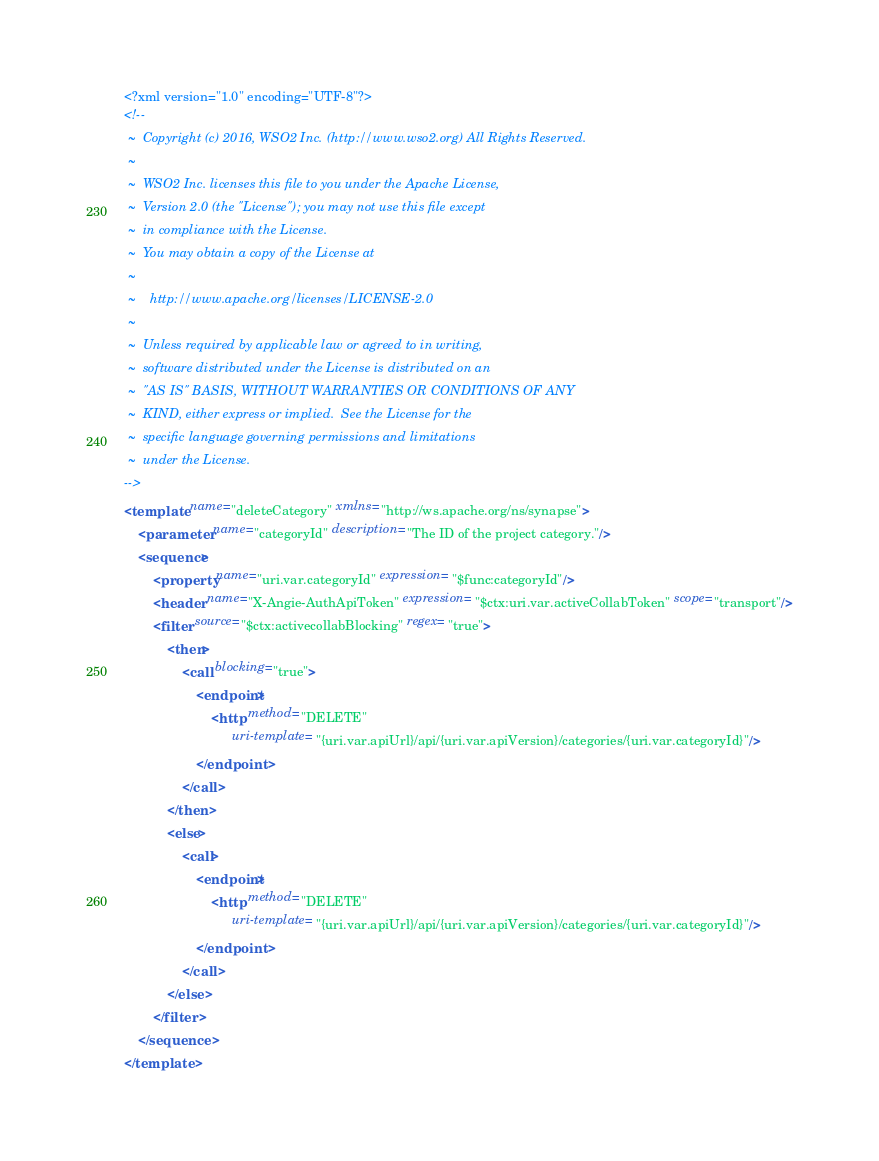<code> <loc_0><loc_0><loc_500><loc_500><_XML_><?xml version="1.0" encoding="UTF-8"?>
<!--
 ~  Copyright (c) 2016, WSO2 Inc. (http://www.wso2.org) All Rights Reserved.
 ~
 ~  WSO2 Inc. licenses this file to you under the Apache License,
 ~  Version 2.0 (the "License"); you may not use this file except
 ~  in compliance with the License.
 ~  You may obtain a copy of the License at
 ~
 ~    http://www.apache.org/licenses/LICENSE-2.0
 ~
 ~  Unless required by applicable law or agreed to in writing,
 ~  software distributed under the License is distributed on an
 ~  "AS IS" BASIS, WITHOUT WARRANTIES OR CONDITIONS OF ANY
 ~  KIND, either express or implied.  See the License for the
 ~  specific language governing permissions and limitations
 ~  under the License.
-->
<template name="deleteCategory" xmlns="http://ws.apache.org/ns/synapse">
    <parameter name="categoryId" description="The ID of the project category."/>
    <sequence>
        <property name="uri.var.categoryId" expression="$func:categoryId"/>
        <header name="X-Angie-AuthApiToken" expression="$ctx:uri.var.activeCollabToken" scope="transport"/>
        <filter source="$ctx:activecollabBlocking" regex="true">
            <then>
                <call blocking="true">
                    <endpoint>
                        <http method="DELETE"
                              uri-template="{uri.var.apiUrl}/api/{uri.var.apiVersion}/categories/{uri.var.categoryId}"/>
                    </endpoint>
                </call>
            </then>
            <else>
                <call>
                    <endpoint>
                        <http method="DELETE"
                              uri-template="{uri.var.apiUrl}/api/{uri.var.apiVersion}/categories/{uri.var.categoryId}"/>
                    </endpoint>
                </call>
            </else>
        </filter>
    </sequence>
</template></code> 